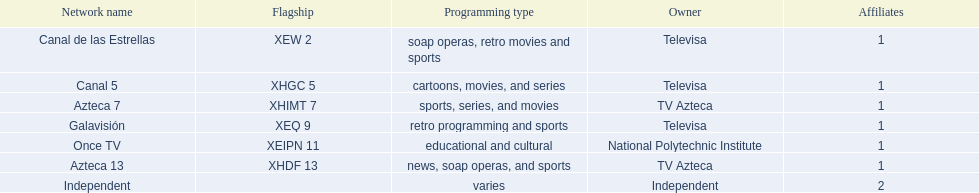What channel is dedicated to airing cartoon shows? Canal 5. What channel mainly features soap operas? Canal de las Estrellas. What channel focuses on sports coverage? Azteca 7. 